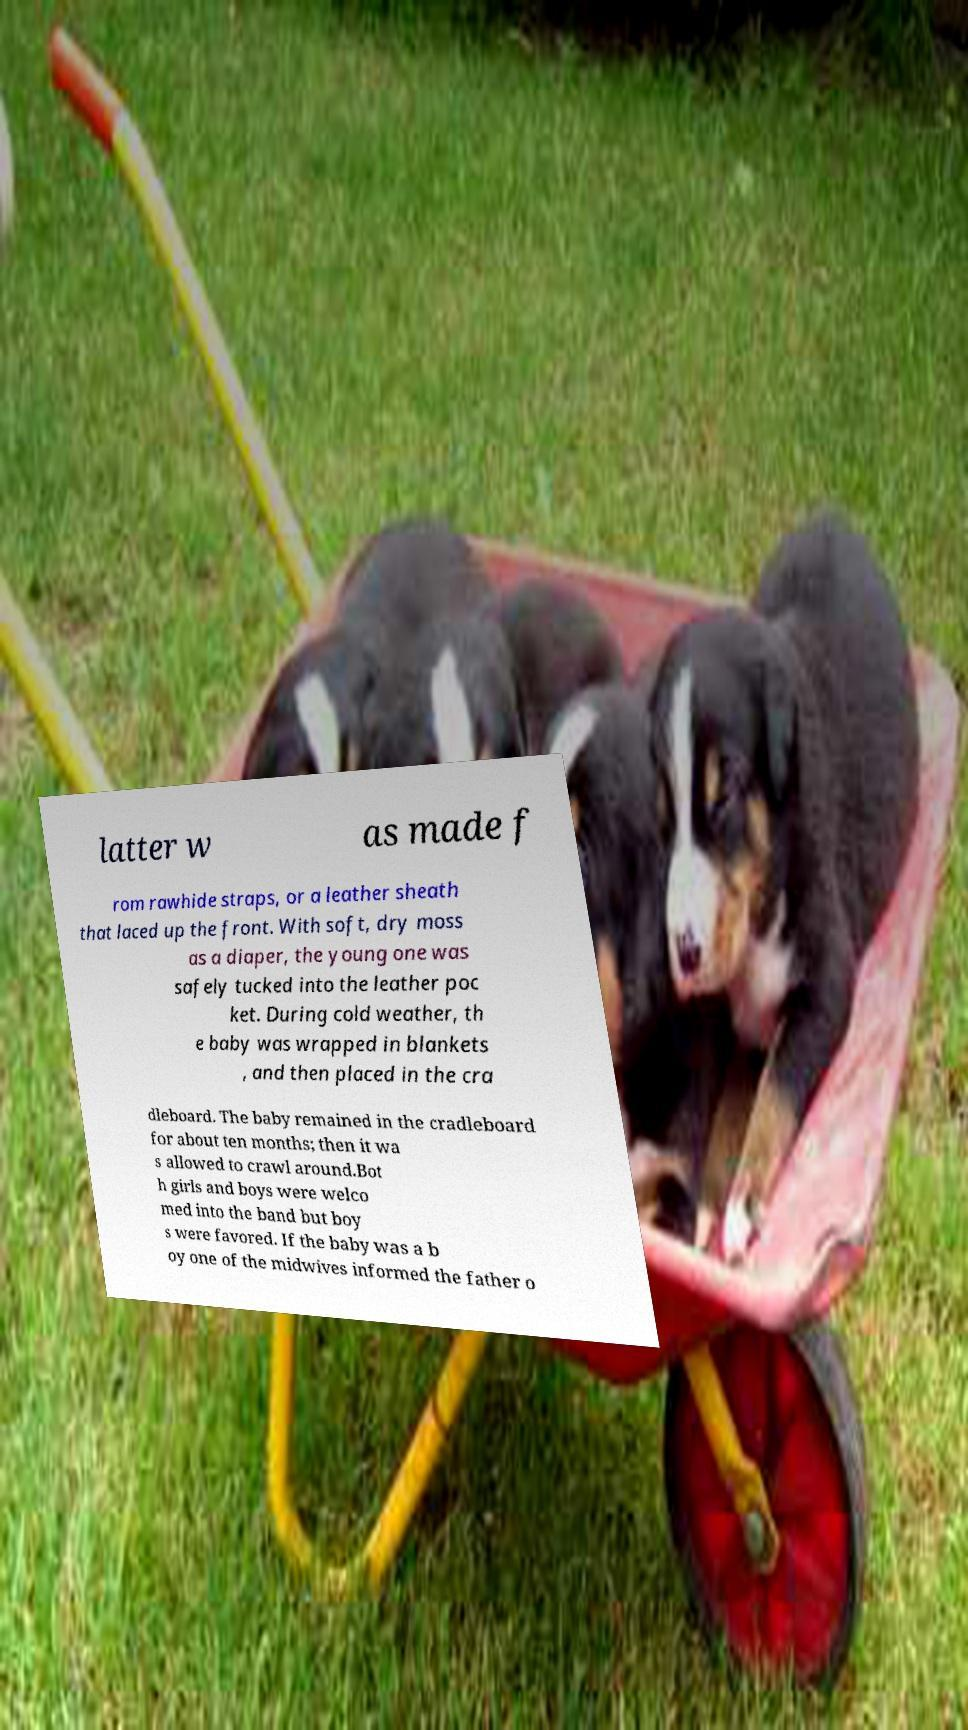Please read and relay the text visible in this image. What does it say? latter w as made f rom rawhide straps, or a leather sheath that laced up the front. With soft, dry moss as a diaper, the young one was safely tucked into the leather poc ket. During cold weather, th e baby was wrapped in blankets , and then placed in the cra dleboard. The baby remained in the cradleboard for about ten months; then it wa s allowed to crawl around.Bot h girls and boys were welco med into the band but boy s were favored. If the baby was a b oy one of the midwives informed the father o 